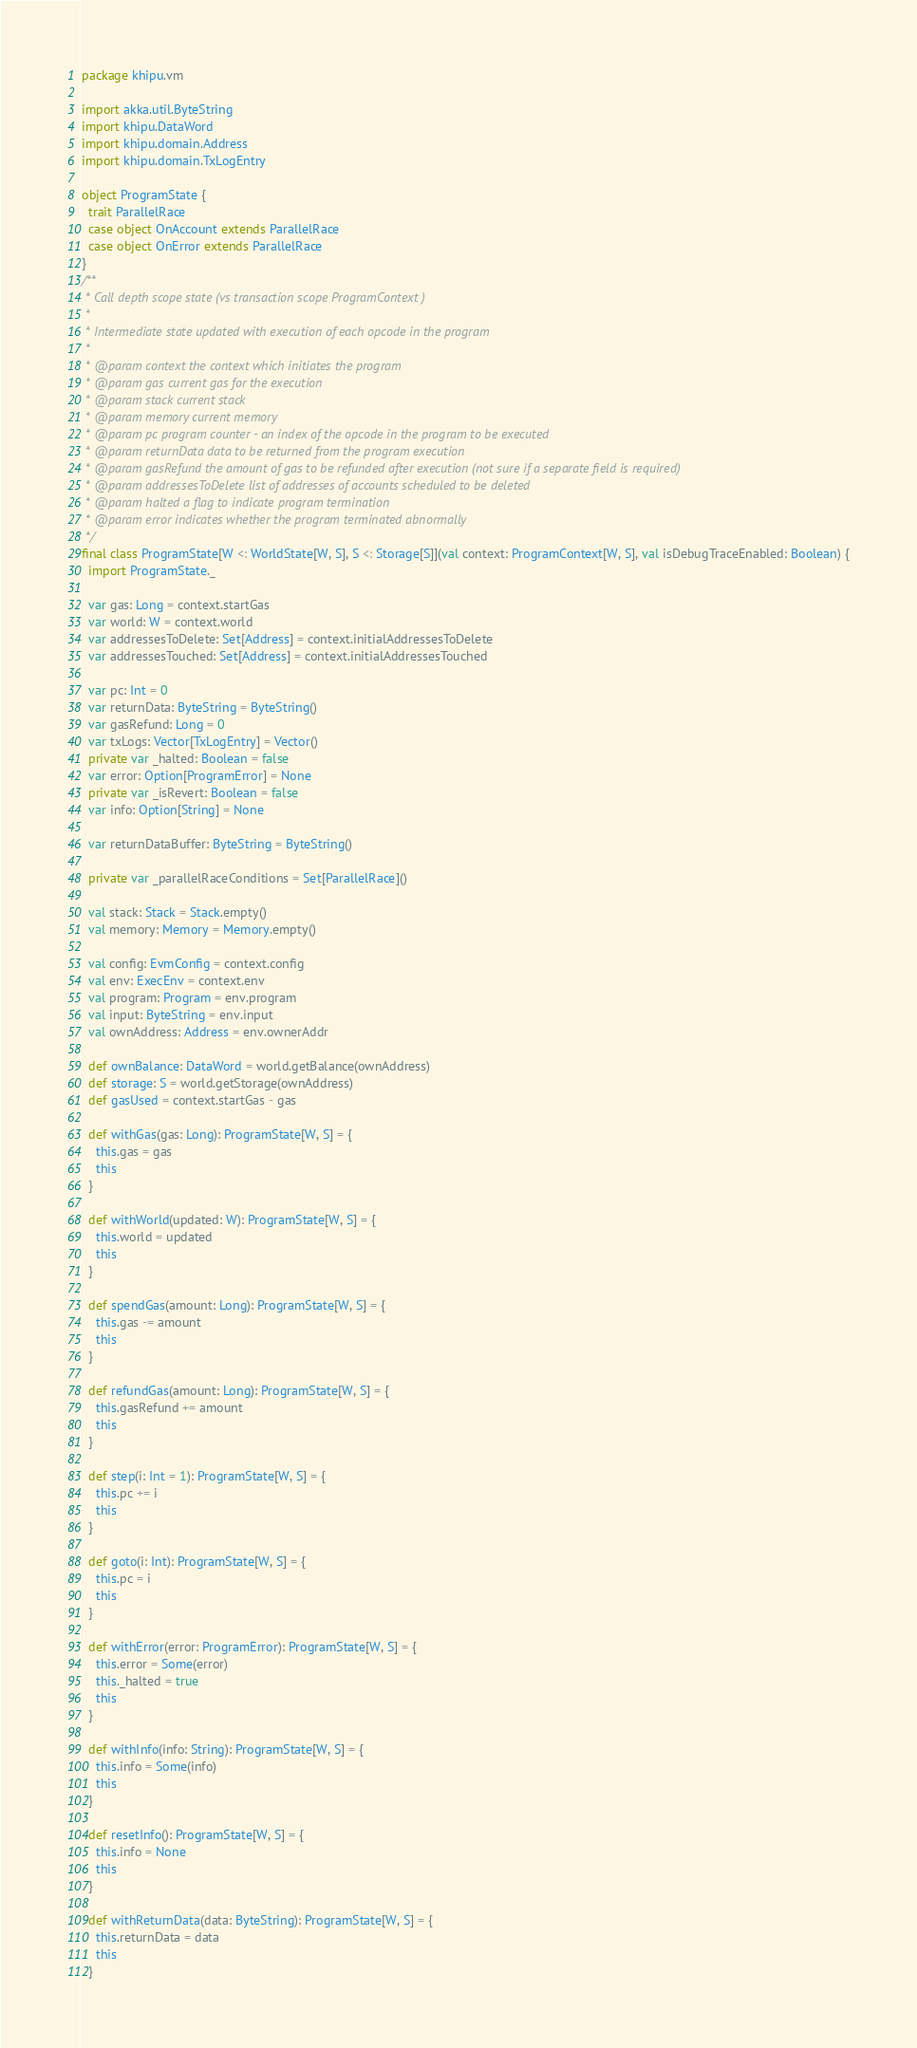<code> <loc_0><loc_0><loc_500><loc_500><_Scala_>package khipu.vm

import akka.util.ByteString
import khipu.DataWord
import khipu.domain.Address
import khipu.domain.TxLogEntry

object ProgramState {
  trait ParallelRace
  case object OnAccount extends ParallelRace
  case object OnError extends ParallelRace
}
/**
 * Call depth scope state (vs transaction scope ProgramContext )
 *
 * Intermediate state updated with execution of each opcode in the program
 *
 * @param context the context which initiates the program
 * @param gas current gas for the execution
 * @param stack current stack
 * @param memory current memory
 * @param pc program counter - an index of the opcode in the program to be executed
 * @param returnData data to be returned from the program execution
 * @param gasRefund the amount of gas to be refunded after execution (not sure if a separate field is required)
 * @param addressesToDelete list of addresses of accounts scheduled to be deleted
 * @param halted a flag to indicate program termination
 * @param error indicates whether the program terminated abnormally
 */
final class ProgramState[W <: WorldState[W, S], S <: Storage[S]](val context: ProgramContext[W, S], val isDebugTraceEnabled: Boolean) {
  import ProgramState._

  var gas: Long = context.startGas
  var world: W = context.world
  var addressesToDelete: Set[Address] = context.initialAddressesToDelete
  var addressesTouched: Set[Address] = context.initialAddressesTouched

  var pc: Int = 0
  var returnData: ByteString = ByteString()
  var gasRefund: Long = 0
  var txLogs: Vector[TxLogEntry] = Vector()
  private var _halted: Boolean = false
  var error: Option[ProgramError] = None
  private var _isRevert: Boolean = false
  var info: Option[String] = None

  var returnDataBuffer: ByteString = ByteString()

  private var _parallelRaceConditions = Set[ParallelRace]()

  val stack: Stack = Stack.empty()
  val memory: Memory = Memory.empty()

  val config: EvmConfig = context.config
  val env: ExecEnv = context.env
  val program: Program = env.program
  val input: ByteString = env.input
  val ownAddress: Address = env.ownerAddr

  def ownBalance: DataWord = world.getBalance(ownAddress)
  def storage: S = world.getStorage(ownAddress)
  def gasUsed = context.startGas - gas

  def withGas(gas: Long): ProgramState[W, S] = {
    this.gas = gas
    this
  }

  def withWorld(updated: W): ProgramState[W, S] = {
    this.world = updated
    this
  }

  def spendGas(amount: Long): ProgramState[W, S] = {
    this.gas -= amount
    this
  }

  def refundGas(amount: Long): ProgramState[W, S] = {
    this.gasRefund += amount
    this
  }

  def step(i: Int = 1): ProgramState[W, S] = {
    this.pc += i
    this
  }

  def goto(i: Int): ProgramState[W, S] = {
    this.pc = i
    this
  }

  def withError(error: ProgramError): ProgramState[W, S] = {
    this.error = Some(error)
    this._halted = true
    this
  }

  def withInfo(info: String): ProgramState[W, S] = {
    this.info = Some(info)
    this
  }

  def resetInfo(): ProgramState[W, S] = {
    this.info = None
    this
  }

  def withReturnData(data: ByteString): ProgramState[W, S] = {
    this.returnData = data
    this
  }
</code> 